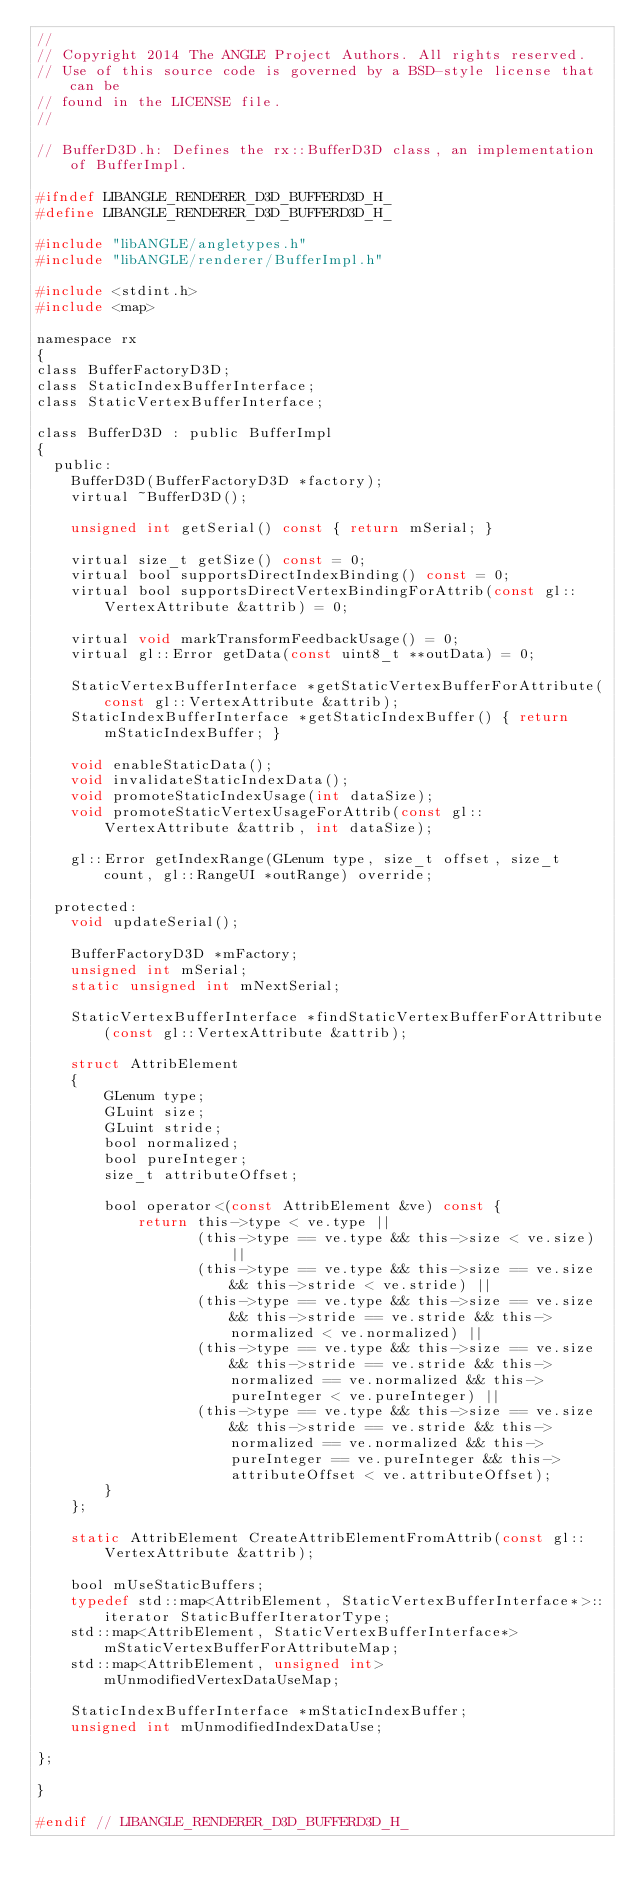<code> <loc_0><loc_0><loc_500><loc_500><_C_>//
// Copyright 2014 The ANGLE Project Authors. All rights reserved.
// Use of this source code is governed by a BSD-style license that can be
// found in the LICENSE file.
//

// BufferD3D.h: Defines the rx::BufferD3D class, an implementation of BufferImpl.

#ifndef LIBANGLE_RENDERER_D3D_BUFFERD3D_H_
#define LIBANGLE_RENDERER_D3D_BUFFERD3D_H_

#include "libANGLE/angletypes.h"
#include "libANGLE/renderer/BufferImpl.h"

#include <stdint.h>
#include <map>

namespace rx
{
class BufferFactoryD3D;
class StaticIndexBufferInterface;
class StaticVertexBufferInterface;

class BufferD3D : public BufferImpl
{
  public:
    BufferD3D(BufferFactoryD3D *factory);
    virtual ~BufferD3D();

    unsigned int getSerial() const { return mSerial; }

    virtual size_t getSize() const = 0;
    virtual bool supportsDirectIndexBinding() const = 0;
    virtual bool supportsDirectVertexBindingForAttrib(const gl::VertexAttribute &attrib) = 0;

    virtual void markTransformFeedbackUsage() = 0;
    virtual gl::Error getData(const uint8_t **outData) = 0;

    StaticVertexBufferInterface *getStaticVertexBufferForAttribute(const gl::VertexAttribute &attrib);
    StaticIndexBufferInterface *getStaticIndexBuffer() { return mStaticIndexBuffer; }

    void enableStaticData();
    void invalidateStaticIndexData();
    void promoteStaticIndexUsage(int dataSize);
    void promoteStaticVertexUsageForAttrib(const gl::VertexAttribute &attrib, int dataSize);

    gl::Error getIndexRange(GLenum type, size_t offset, size_t count, gl::RangeUI *outRange) override;

  protected:
    void updateSerial();

    BufferFactoryD3D *mFactory;
    unsigned int mSerial;
    static unsigned int mNextSerial;

    StaticVertexBufferInterface *findStaticVertexBufferForAttribute(const gl::VertexAttribute &attrib);

    struct AttribElement
    {
        GLenum type;
        GLuint size;
        GLuint stride;
        bool normalized;
        bool pureInteger;
        size_t attributeOffset;

        bool operator<(const AttribElement &ve) const {
            return this->type < ve.type ||
                   (this->type == ve.type && this->size < ve.size) ||
                   (this->type == ve.type && this->size == ve.size && this->stride < ve.stride) ||
                   (this->type == ve.type && this->size == ve.size && this->stride == ve.stride && this->normalized < ve.normalized) ||
                   (this->type == ve.type && this->size == ve.size && this->stride == ve.stride && this->normalized == ve.normalized && this->pureInteger < ve.pureInteger) ||
                   (this->type == ve.type && this->size == ve.size && this->stride == ve.stride && this->normalized == ve.normalized && this->pureInteger == ve.pureInteger && this->attributeOffset < ve.attributeOffset);
        }
    };

    static AttribElement CreateAttribElementFromAttrib(const gl::VertexAttribute &attrib);

    bool mUseStaticBuffers;
    typedef std::map<AttribElement, StaticVertexBufferInterface*>::iterator StaticBufferIteratorType;
    std::map<AttribElement, StaticVertexBufferInterface*> mStaticVertexBufferForAttributeMap;
    std::map<AttribElement, unsigned int> mUnmodifiedVertexDataUseMap;

    StaticIndexBufferInterface *mStaticIndexBuffer;
    unsigned int mUnmodifiedIndexDataUse;

};

}

#endif // LIBANGLE_RENDERER_D3D_BUFFERD3D_H_
</code> 